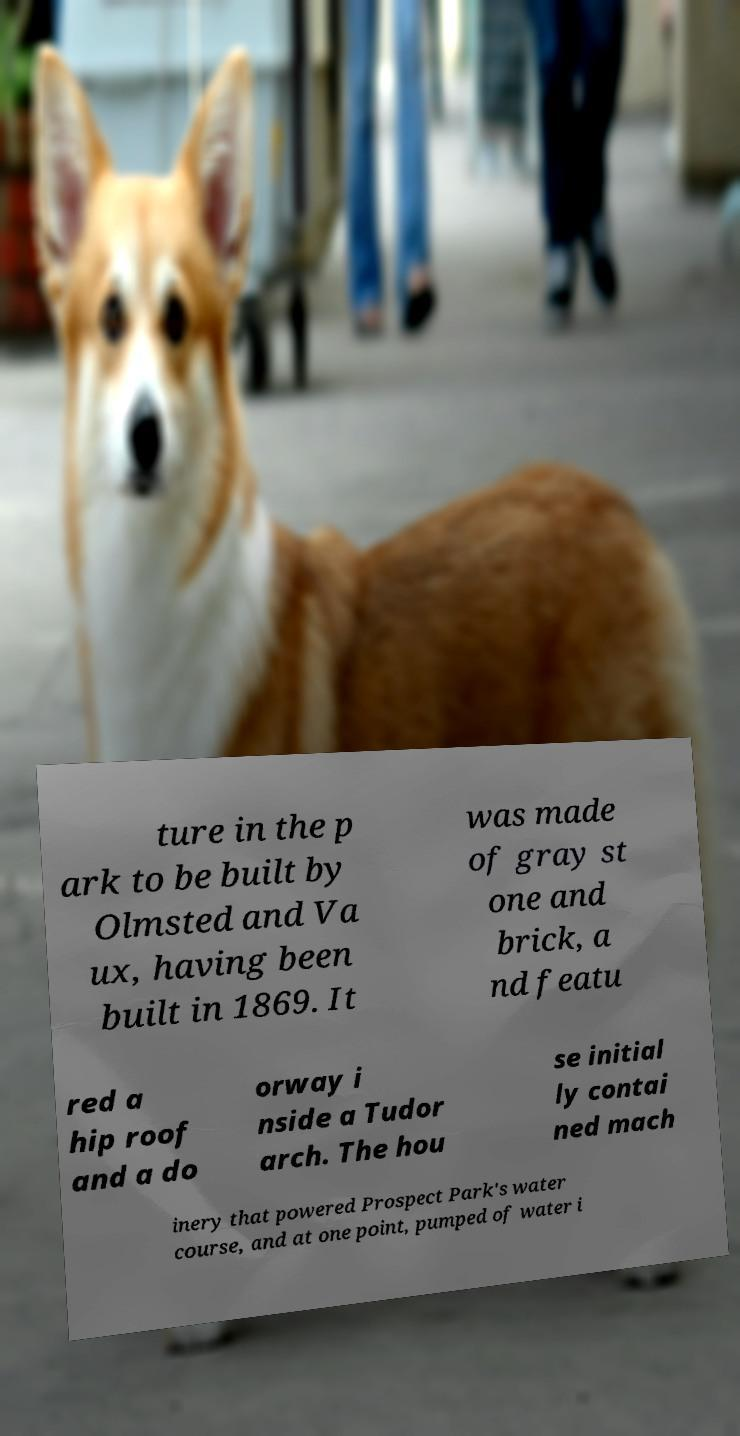Could you extract and type out the text from this image? ture in the p ark to be built by Olmsted and Va ux, having been built in 1869. It was made of gray st one and brick, a nd featu red a hip roof and a do orway i nside a Tudor arch. The hou se initial ly contai ned mach inery that powered Prospect Park's water course, and at one point, pumped of water i 